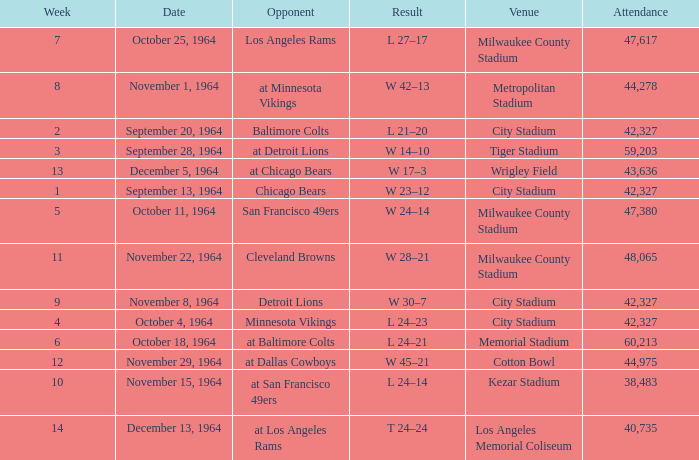What is the average week of the game on November 22, 1964 attended by 48,065? None. 